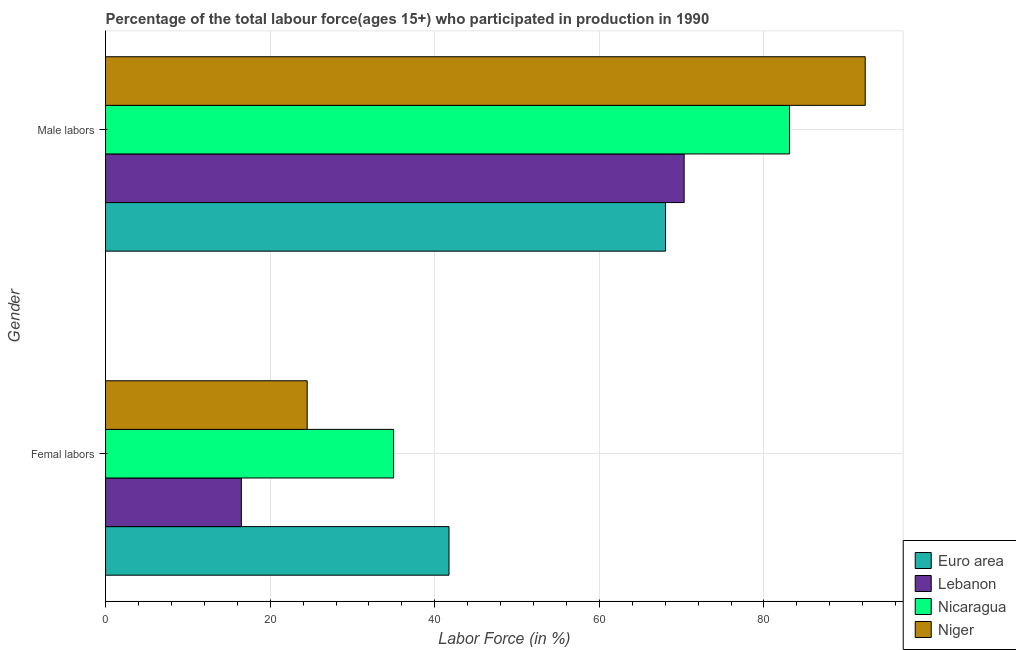Are the number of bars per tick equal to the number of legend labels?
Offer a terse response. Yes. How many bars are there on the 1st tick from the bottom?
Provide a short and direct response. 4. What is the label of the 1st group of bars from the top?
Provide a succinct answer. Male labors. What is the percentage of female labor force in Nicaragua?
Keep it short and to the point. 35. Across all countries, what is the maximum percentage of female labor force?
Offer a terse response. 41.73. Across all countries, what is the minimum percentage of female labor force?
Your answer should be compact. 16.5. In which country was the percentage of female labor force maximum?
Give a very brief answer. Euro area. What is the total percentage of female labor force in the graph?
Keep it short and to the point. 117.73. What is the difference between the percentage of male labour force in Niger and that in Euro area?
Offer a terse response. 24.26. What is the difference between the percentage of female labor force in Euro area and the percentage of male labour force in Niger?
Offer a very short reply. -50.57. What is the average percentage of male labour force per country?
Ensure brevity in your answer.  78.44. What is the difference between the percentage of female labor force and percentage of male labour force in Euro area?
Ensure brevity in your answer.  -26.31. In how many countries, is the percentage of female labor force greater than 48 %?
Your response must be concise. 0. What is the ratio of the percentage of male labour force in Niger to that in Euro area?
Your response must be concise. 1.36. Is the percentage of female labor force in Lebanon less than that in Nicaragua?
Provide a succinct answer. Yes. What does the 2nd bar from the top in Male labors represents?
Your answer should be very brief. Nicaragua. What does the 4th bar from the bottom in Femal labors represents?
Your answer should be very brief. Niger. What is the difference between two consecutive major ticks on the X-axis?
Make the answer very short. 20. Are the values on the major ticks of X-axis written in scientific E-notation?
Offer a terse response. No. Does the graph contain grids?
Provide a succinct answer. Yes. How many legend labels are there?
Provide a succinct answer. 4. What is the title of the graph?
Your response must be concise. Percentage of the total labour force(ages 15+) who participated in production in 1990. Does "Papua New Guinea" appear as one of the legend labels in the graph?
Your answer should be compact. No. What is the Labor Force (in %) of Euro area in Femal labors?
Ensure brevity in your answer.  41.73. What is the Labor Force (in %) in Euro area in Male labors?
Make the answer very short. 68.04. What is the Labor Force (in %) of Lebanon in Male labors?
Your response must be concise. 70.3. What is the Labor Force (in %) of Nicaragua in Male labors?
Provide a short and direct response. 83.1. What is the Labor Force (in %) of Niger in Male labors?
Keep it short and to the point. 92.3. Across all Gender, what is the maximum Labor Force (in %) of Euro area?
Your answer should be compact. 68.04. Across all Gender, what is the maximum Labor Force (in %) of Lebanon?
Give a very brief answer. 70.3. Across all Gender, what is the maximum Labor Force (in %) in Nicaragua?
Provide a succinct answer. 83.1. Across all Gender, what is the maximum Labor Force (in %) in Niger?
Your response must be concise. 92.3. Across all Gender, what is the minimum Labor Force (in %) in Euro area?
Make the answer very short. 41.73. Across all Gender, what is the minimum Labor Force (in %) of Lebanon?
Your answer should be very brief. 16.5. Across all Gender, what is the minimum Labor Force (in %) in Niger?
Ensure brevity in your answer.  24.5. What is the total Labor Force (in %) in Euro area in the graph?
Make the answer very short. 109.77. What is the total Labor Force (in %) in Lebanon in the graph?
Give a very brief answer. 86.8. What is the total Labor Force (in %) in Nicaragua in the graph?
Your answer should be very brief. 118.1. What is the total Labor Force (in %) in Niger in the graph?
Provide a short and direct response. 116.8. What is the difference between the Labor Force (in %) of Euro area in Femal labors and that in Male labors?
Your answer should be compact. -26.31. What is the difference between the Labor Force (in %) of Lebanon in Femal labors and that in Male labors?
Ensure brevity in your answer.  -53.8. What is the difference between the Labor Force (in %) in Nicaragua in Femal labors and that in Male labors?
Your response must be concise. -48.1. What is the difference between the Labor Force (in %) in Niger in Femal labors and that in Male labors?
Provide a short and direct response. -67.8. What is the difference between the Labor Force (in %) of Euro area in Femal labors and the Labor Force (in %) of Lebanon in Male labors?
Keep it short and to the point. -28.57. What is the difference between the Labor Force (in %) in Euro area in Femal labors and the Labor Force (in %) in Nicaragua in Male labors?
Give a very brief answer. -41.37. What is the difference between the Labor Force (in %) of Euro area in Femal labors and the Labor Force (in %) of Niger in Male labors?
Offer a very short reply. -50.57. What is the difference between the Labor Force (in %) of Lebanon in Femal labors and the Labor Force (in %) of Nicaragua in Male labors?
Provide a succinct answer. -66.6. What is the difference between the Labor Force (in %) of Lebanon in Femal labors and the Labor Force (in %) of Niger in Male labors?
Your response must be concise. -75.8. What is the difference between the Labor Force (in %) in Nicaragua in Femal labors and the Labor Force (in %) in Niger in Male labors?
Offer a terse response. -57.3. What is the average Labor Force (in %) of Euro area per Gender?
Provide a succinct answer. 54.88. What is the average Labor Force (in %) of Lebanon per Gender?
Provide a short and direct response. 43.4. What is the average Labor Force (in %) in Nicaragua per Gender?
Offer a terse response. 59.05. What is the average Labor Force (in %) in Niger per Gender?
Your answer should be very brief. 58.4. What is the difference between the Labor Force (in %) in Euro area and Labor Force (in %) in Lebanon in Femal labors?
Provide a succinct answer. 25.23. What is the difference between the Labor Force (in %) of Euro area and Labor Force (in %) of Nicaragua in Femal labors?
Your answer should be very brief. 6.73. What is the difference between the Labor Force (in %) in Euro area and Labor Force (in %) in Niger in Femal labors?
Keep it short and to the point. 17.23. What is the difference between the Labor Force (in %) in Lebanon and Labor Force (in %) in Nicaragua in Femal labors?
Offer a very short reply. -18.5. What is the difference between the Labor Force (in %) of Lebanon and Labor Force (in %) of Niger in Femal labors?
Keep it short and to the point. -8. What is the difference between the Labor Force (in %) of Nicaragua and Labor Force (in %) of Niger in Femal labors?
Make the answer very short. 10.5. What is the difference between the Labor Force (in %) in Euro area and Labor Force (in %) in Lebanon in Male labors?
Give a very brief answer. -2.26. What is the difference between the Labor Force (in %) in Euro area and Labor Force (in %) in Nicaragua in Male labors?
Offer a very short reply. -15.06. What is the difference between the Labor Force (in %) in Euro area and Labor Force (in %) in Niger in Male labors?
Provide a short and direct response. -24.26. What is the difference between the Labor Force (in %) in Lebanon and Labor Force (in %) in Nicaragua in Male labors?
Your answer should be very brief. -12.8. What is the difference between the Labor Force (in %) of Lebanon and Labor Force (in %) of Niger in Male labors?
Keep it short and to the point. -22. What is the difference between the Labor Force (in %) of Nicaragua and Labor Force (in %) of Niger in Male labors?
Give a very brief answer. -9.2. What is the ratio of the Labor Force (in %) in Euro area in Femal labors to that in Male labors?
Your answer should be very brief. 0.61. What is the ratio of the Labor Force (in %) of Lebanon in Femal labors to that in Male labors?
Your answer should be compact. 0.23. What is the ratio of the Labor Force (in %) of Nicaragua in Femal labors to that in Male labors?
Offer a terse response. 0.42. What is the ratio of the Labor Force (in %) in Niger in Femal labors to that in Male labors?
Offer a very short reply. 0.27. What is the difference between the highest and the second highest Labor Force (in %) of Euro area?
Ensure brevity in your answer.  26.31. What is the difference between the highest and the second highest Labor Force (in %) in Lebanon?
Keep it short and to the point. 53.8. What is the difference between the highest and the second highest Labor Force (in %) in Nicaragua?
Ensure brevity in your answer.  48.1. What is the difference between the highest and the second highest Labor Force (in %) of Niger?
Make the answer very short. 67.8. What is the difference between the highest and the lowest Labor Force (in %) of Euro area?
Make the answer very short. 26.31. What is the difference between the highest and the lowest Labor Force (in %) in Lebanon?
Your response must be concise. 53.8. What is the difference between the highest and the lowest Labor Force (in %) in Nicaragua?
Your response must be concise. 48.1. What is the difference between the highest and the lowest Labor Force (in %) in Niger?
Keep it short and to the point. 67.8. 